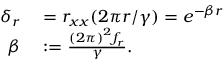<formula> <loc_0><loc_0><loc_500><loc_500>\begin{array} { r l } { \delta _ { r } } & = r _ { x x } ( 2 \pi r / \gamma ) = e ^ { - \beta r } } \\ { \beta } & \colon = \frac { \left ( 2 \pi \right ) ^ { 2 } f _ { r } } { \gamma } . } \end{array}</formula> 